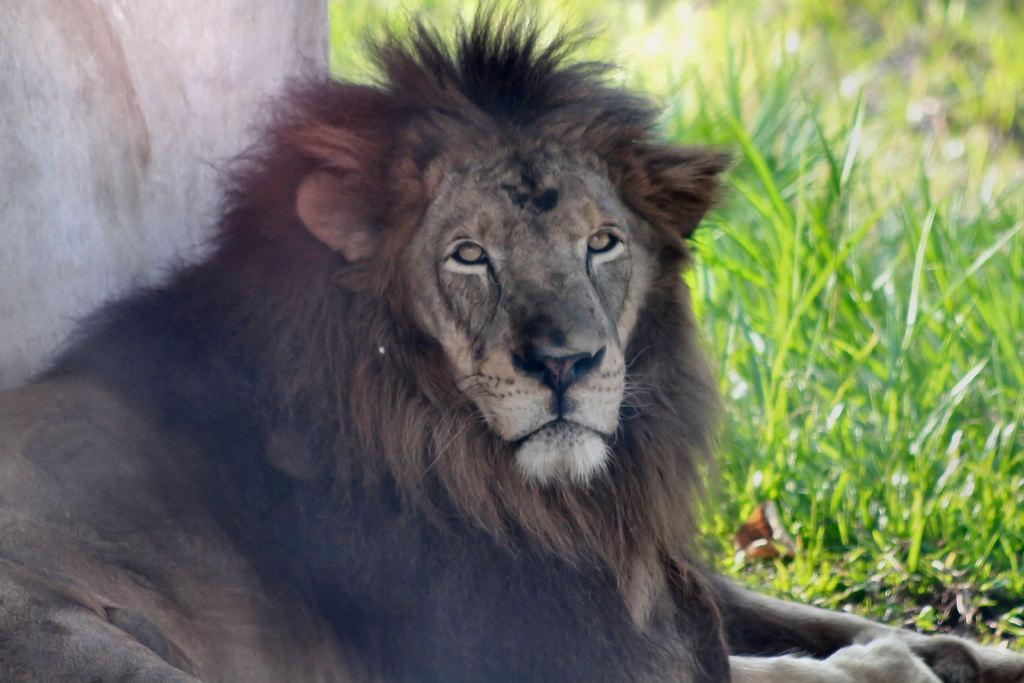What type of vegetation is present in the image? There is grass in the image. What animal can be seen in the middle of the image? There is a lion in the middle of the image. What type of liquid can be seen in the image? There is no liquid present in the image; it features grass and a lion. Is the lion in the image located in space? No, the lion is not in space; it is on the grass in the image. 